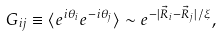Convert formula to latex. <formula><loc_0><loc_0><loc_500><loc_500>G _ { i j } \equiv \langle e ^ { i \theta _ { i } } e ^ { - i \theta _ { j } } \rangle \sim e ^ { - | { \vec { R } } _ { i } - { \vec { R } } _ { j } | / \xi } ,</formula> 